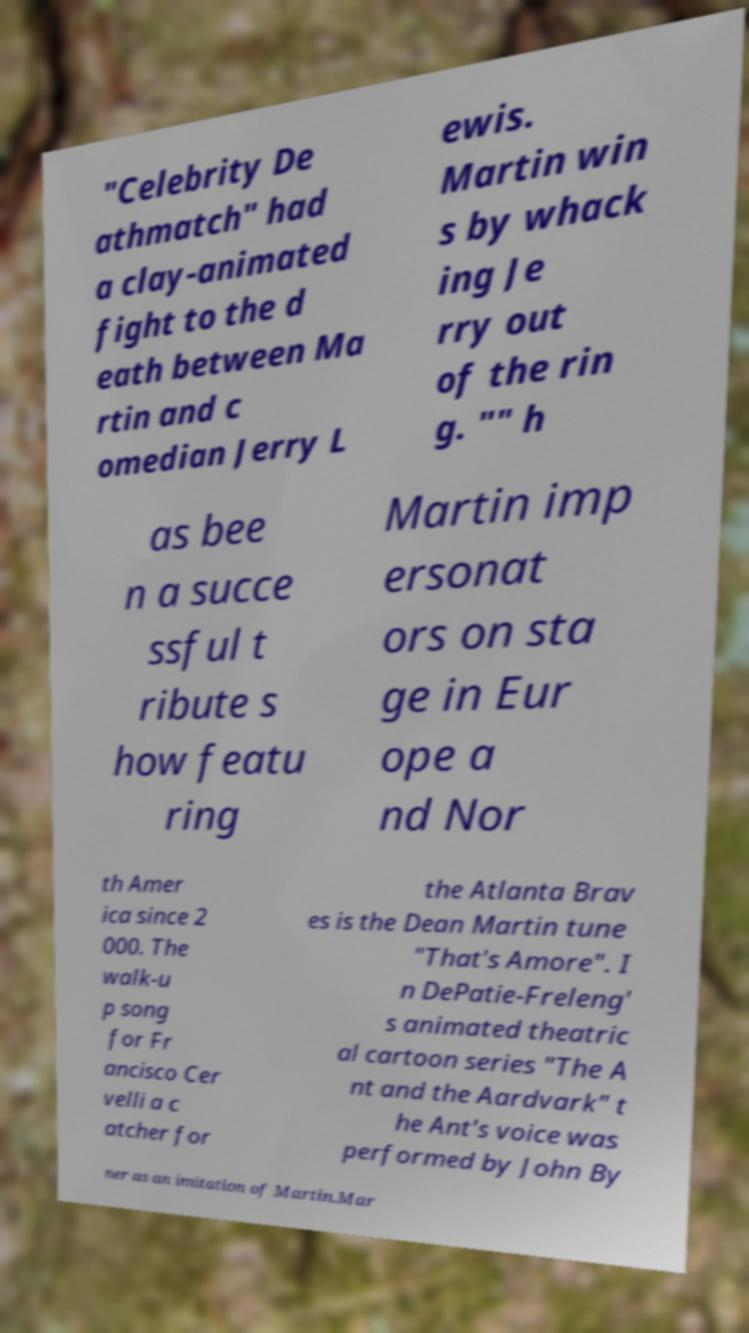What messages or text are displayed in this image? I need them in a readable, typed format. "Celebrity De athmatch" had a clay-animated fight to the d eath between Ma rtin and c omedian Jerry L ewis. Martin win s by whack ing Je rry out of the rin g. "" h as bee n a succe ssful t ribute s how featu ring Martin imp ersonat ors on sta ge in Eur ope a nd Nor th Amer ica since 2 000. The walk-u p song for Fr ancisco Cer velli a c atcher for the Atlanta Brav es is the Dean Martin tune "That's Amore". I n DePatie-Freleng' s animated theatric al cartoon series "The A nt and the Aardvark" t he Ant's voice was performed by John By ner as an imitation of Martin.Mar 